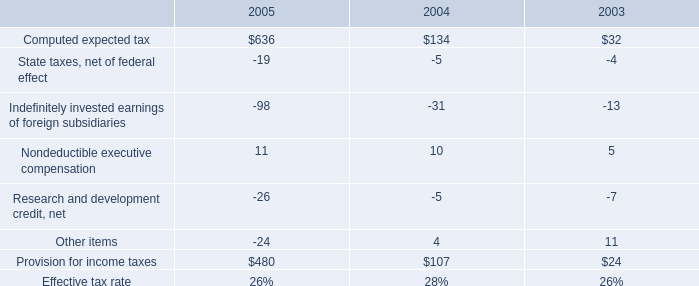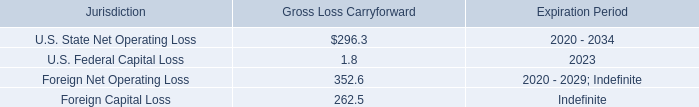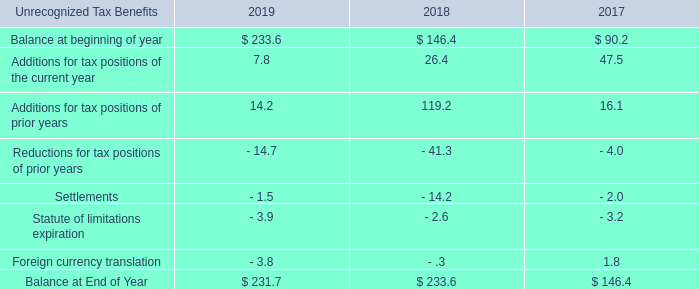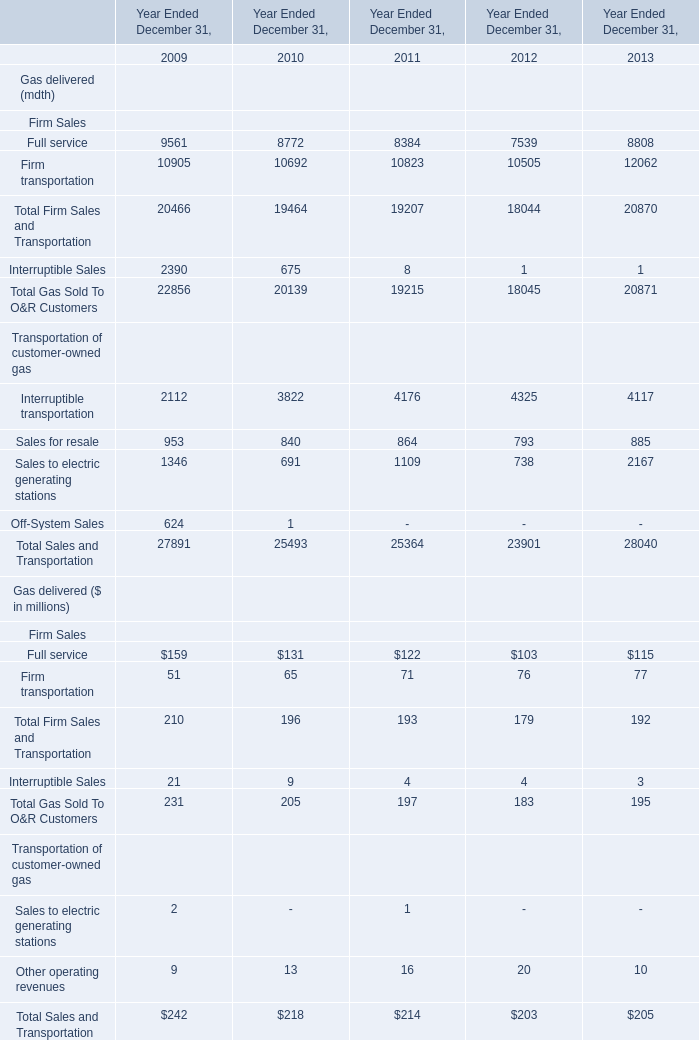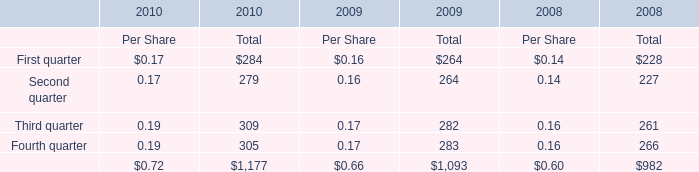What will Total Sales and Transportation in terms of Gas delivered ($ in millions) reach in 2014 if it continues to grow at its current rate? (in million) 
Computations: (205 * (1 + ((205 - 203) / 203)))
Answer: 207.0197. 